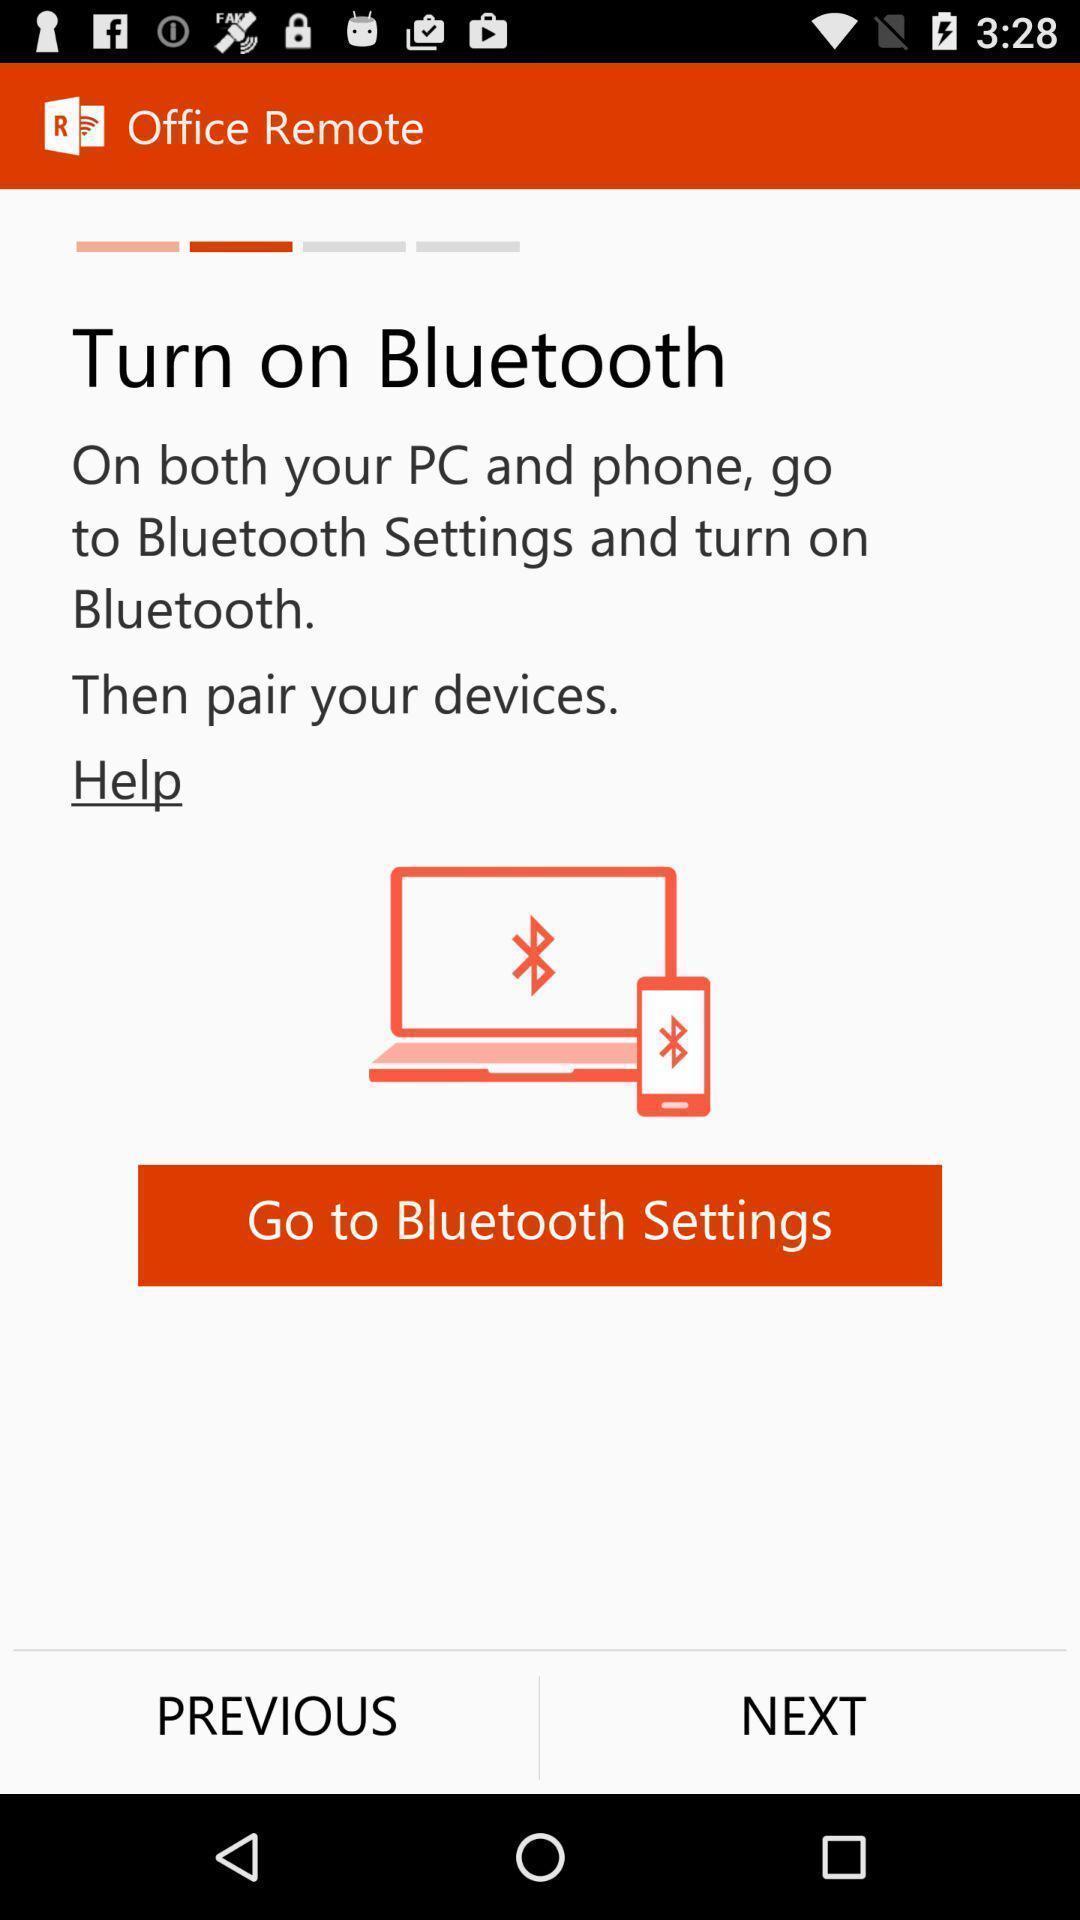What can you discern from this picture? Screen displaying features information. 